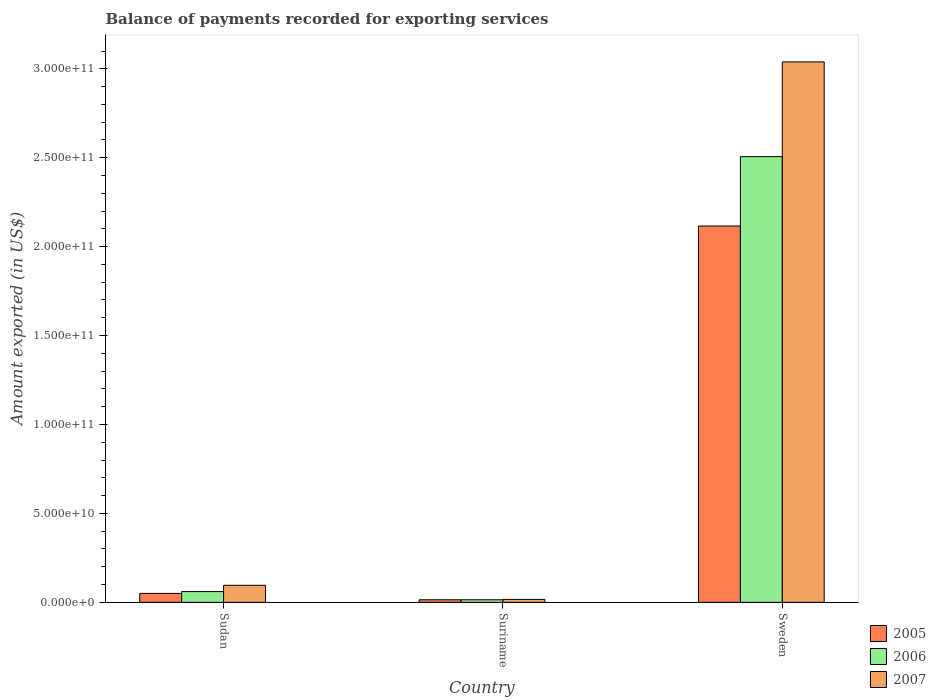How many different coloured bars are there?
Make the answer very short. 3. Are the number of bars on each tick of the X-axis equal?
Offer a very short reply. Yes. How many bars are there on the 1st tick from the left?
Offer a terse response. 3. What is the label of the 1st group of bars from the left?
Your answer should be very brief. Sudan. In how many cases, is the number of bars for a given country not equal to the number of legend labels?
Offer a very short reply. 0. What is the amount exported in 2006 in Sudan?
Keep it short and to the point. 6.04e+09. Across all countries, what is the maximum amount exported in 2007?
Give a very brief answer. 3.04e+11. Across all countries, what is the minimum amount exported in 2007?
Your answer should be very brief. 1.66e+09. In which country was the amount exported in 2006 maximum?
Offer a very short reply. Sweden. In which country was the amount exported in 2007 minimum?
Give a very brief answer. Suriname. What is the total amount exported in 2007 in the graph?
Your answer should be compact. 3.15e+11. What is the difference between the amount exported in 2005 in Sudan and that in Suriname?
Provide a short and direct response. 3.58e+09. What is the difference between the amount exported in 2007 in Suriname and the amount exported in 2005 in Sudan?
Offer a terse response. -3.36e+09. What is the average amount exported in 2006 per country?
Offer a terse response. 8.60e+1. What is the difference between the amount exported of/in 2006 and amount exported of/in 2007 in Sweden?
Make the answer very short. -5.33e+1. In how many countries, is the amount exported in 2007 greater than 300000000000 US$?
Ensure brevity in your answer.  1. What is the ratio of the amount exported in 2006 in Sudan to that in Suriname?
Your answer should be compact. 4.21. Is the difference between the amount exported in 2006 in Suriname and Sweden greater than the difference between the amount exported in 2007 in Suriname and Sweden?
Offer a very short reply. Yes. What is the difference between the highest and the second highest amount exported in 2006?
Provide a short and direct response. -4.61e+09. What is the difference between the highest and the lowest amount exported in 2007?
Keep it short and to the point. 3.02e+11. What does the 3rd bar from the left in Sudan represents?
Keep it short and to the point. 2007. What does the 1st bar from the right in Sudan represents?
Make the answer very short. 2007. How many bars are there?
Your answer should be very brief. 9. Are all the bars in the graph horizontal?
Keep it short and to the point. No. What is the difference between two consecutive major ticks on the Y-axis?
Make the answer very short. 5.00e+1. Are the values on the major ticks of Y-axis written in scientific E-notation?
Give a very brief answer. Yes. Does the graph contain any zero values?
Your answer should be very brief. No. Where does the legend appear in the graph?
Make the answer very short. Bottom right. What is the title of the graph?
Ensure brevity in your answer.  Balance of payments recorded for exporting services. What is the label or title of the Y-axis?
Ensure brevity in your answer.  Amount exported (in US$). What is the Amount exported (in US$) in 2005 in Sudan?
Keep it short and to the point. 5.02e+09. What is the Amount exported (in US$) in 2006 in Sudan?
Keep it short and to the point. 6.04e+09. What is the Amount exported (in US$) of 2007 in Sudan?
Make the answer very short. 9.58e+09. What is the Amount exported (in US$) in 2005 in Suriname?
Offer a terse response. 1.44e+09. What is the Amount exported (in US$) of 2006 in Suriname?
Offer a terse response. 1.44e+09. What is the Amount exported (in US$) in 2007 in Suriname?
Keep it short and to the point. 1.66e+09. What is the Amount exported (in US$) of 2005 in Sweden?
Offer a terse response. 2.12e+11. What is the Amount exported (in US$) in 2006 in Sweden?
Offer a terse response. 2.51e+11. What is the Amount exported (in US$) in 2007 in Sweden?
Offer a terse response. 3.04e+11. Across all countries, what is the maximum Amount exported (in US$) of 2005?
Ensure brevity in your answer.  2.12e+11. Across all countries, what is the maximum Amount exported (in US$) of 2006?
Give a very brief answer. 2.51e+11. Across all countries, what is the maximum Amount exported (in US$) in 2007?
Keep it short and to the point. 3.04e+11. Across all countries, what is the minimum Amount exported (in US$) of 2005?
Make the answer very short. 1.44e+09. Across all countries, what is the minimum Amount exported (in US$) in 2006?
Keep it short and to the point. 1.44e+09. Across all countries, what is the minimum Amount exported (in US$) of 2007?
Offer a very short reply. 1.66e+09. What is the total Amount exported (in US$) in 2005 in the graph?
Your answer should be very brief. 2.18e+11. What is the total Amount exported (in US$) in 2006 in the graph?
Provide a short and direct response. 2.58e+11. What is the total Amount exported (in US$) of 2007 in the graph?
Offer a very short reply. 3.15e+11. What is the difference between the Amount exported (in US$) in 2005 in Sudan and that in Suriname?
Make the answer very short. 3.58e+09. What is the difference between the Amount exported (in US$) in 2006 in Sudan and that in Suriname?
Give a very brief answer. 4.61e+09. What is the difference between the Amount exported (in US$) in 2007 in Sudan and that in Suriname?
Keep it short and to the point. 7.93e+09. What is the difference between the Amount exported (in US$) in 2005 in Sudan and that in Sweden?
Your answer should be compact. -2.07e+11. What is the difference between the Amount exported (in US$) in 2006 in Sudan and that in Sweden?
Offer a terse response. -2.45e+11. What is the difference between the Amount exported (in US$) in 2007 in Sudan and that in Sweden?
Make the answer very short. -2.94e+11. What is the difference between the Amount exported (in US$) of 2005 in Suriname and that in Sweden?
Your response must be concise. -2.10e+11. What is the difference between the Amount exported (in US$) of 2006 in Suriname and that in Sweden?
Your response must be concise. -2.49e+11. What is the difference between the Amount exported (in US$) of 2007 in Suriname and that in Sweden?
Ensure brevity in your answer.  -3.02e+11. What is the difference between the Amount exported (in US$) in 2005 in Sudan and the Amount exported (in US$) in 2006 in Suriname?
Your response must be concise. 3.58e+09. What is the difference between the Amount exported (in US$) in 2005 in Sudan and the Amount exported (in US$) in 2007 in Suriname?
Offer a very short reply. 3.36e+09. What is the difference between the Amount exported (in US$) in 2006 in Sudan and the Amount exported (in US$) in 2007 in Suriname?
Provide a succinct answer. 4.39e+09. What is the difference between the Amount exported (in US$) of 2005 in Sudan and the Amount exported (in US$) of 2006 in Sweden?
Offer a terse response. -2.46e+11. What is the difference between the Amount exported (in US$) in 2005 in Sudan and the Amount exported (in US$) in 2007 in Sweden?
Provide a short and direct response. -2.99e+11. What is the difference between the Amount exported (in US$) in 2006 in Sudan and the Amount exported (in US$) in 2007 in Sweden?
Make the answer very short. -2.98e+11. What is the difference between the Amount exported (in US$) in 2005 in Suriname and the Amount exported (in US$) in 2006 in Sweden?
Offer a terse response. -2.49e+11. What is the difference between the Amount exported (in US$) of 2005 in Suriname and the Amount exported (in US$) of 2007 in Sweden?
Give a very brief answer. -3.02e+11. What is the difference between the Amount exported (in US$) in 2006 in Suriname and the Amount exported (in US$) in 2007 in Sweden?
Your answer should be compact. -3.02e+11. What is the average Amount exported (in US$) in 2005 per country?
Give a very brief answer. 7.27e+1. What is the average Amount exported (in US$) in 2006 per country?
Keep it short and to the point. 8.60e+1. What is the average Amount exported (in US$) of 2007 per country?
Your answer should be compact. 1.05e+11. What is the difference between the Amount exported (in US$) in 2005 and Amount exported (in US$) in 2006 in Sudan?
Your response must be concise. -1.03e+09. What is the difference between the Amount exported (in US$) in 2005 and Amount exported (in US$) in 2007 in Sudan?
Your answer should be very brief. -4.56e+09. What is the difference between the Amount exported (in US$) of 2006 and Amount exported (in US$) of 2007 in Sudan?
Provide a short and direct response. -3.54e+09. What is the difference between the Amount exported (in US$) in 2005 and Amount exported (in US$) in 2006 in Suriname?
Your answer should be compact. 3.50e+06. What is the difference between the Amount exported (in US$) of 2005 and Amount exported (in US$) of 2007 in Suriname?
Your response must be concise. -2.16e+08. What is the difference between the Amount exported (in US$) in 2006 and Amount exported (in US$) in 2007 in Suriname?
Keep it short and to the point. -2.20e+08. What is the difference between the Amount exported (in US$) of 2005 and Amount exported (in US$) of 2006 in Sweden?
Your answer should be very brief. -3.90e+1. What is the difference between the Amount exported (in US$) of 2005 and Amount exported (in US$) of 2007 in Sweden?
Your answer should be compact. -9.23e+1. What is the difference between the Amount exported (in US$) in 2006 and Amount exported (in US$) in 2007 in Sweden?
Provide a short and direct response. -5.33e+1. What is the ratio of the Amount exported (in US$) in 2005 in Sudan to that in Suriname?
Provide a short and direct response. 3.49. What is the ratio of the Amount exported (in US$) of 2006 in Sudan to that in Suriname?
Your response must be concise. 4.21. What is the ratio of the Amount exported (in US$) of 2007 in Sudan to that in Suriname?
Give a very brief answer. 5.79. What is the ratio of the Amount exported (in US$) in 2005 in Sudan to that in Sweden?
Ensure brevity in your answer.  0.02. What is the ratio of the Amount exported (in US$) in 2006 in Sudan to that in Sweden?
Provide a succinct answer. 0.02. What is the ratio of the Amount exported (in US$) of 2007 in Sudan to that in Sweden?
Give a very brief answer. 0.03. What is the ratio of the Amount exported (in US$) in 2005 in Suriname to that in Sweden?
Keep it short and to the point. 0.01. What is the ratio of the Amount exported (in US$) of 2006 in Suriname to that in Sweden?
Your answer should be compact. 0.01. What is the ratio of the Amount exported (in US$) of 2007 in Suriname to that in Sweden?
Offer a very short reply. 0.01. What is the difference between the highest and the second highest Amount exported (in US$) in 2005?
Offer a terse response. 2.07e+11. What is the difference between the highest and the second highest Amount exported (in US$) in 2006?
Keep it short and to the point. 2.45e+11. What is the difference between the highest and the second highest Amount exported (in US$) in 2007?
Offer a very short reply. 2.94e+11. What is the difference between the highest and the lowest Amount exported (in US$) of 2005?
Provide a short and direct response. 2.10e+11. What is the difference between the highest and the lowest Amount exported (in US$) of 2006?
Your answer should be compact. 2.49e+11. What is the difference between the highest and the lowest Amount exported (in US$) of 2007?
Provide a short and direct response. 3.02e+11. 